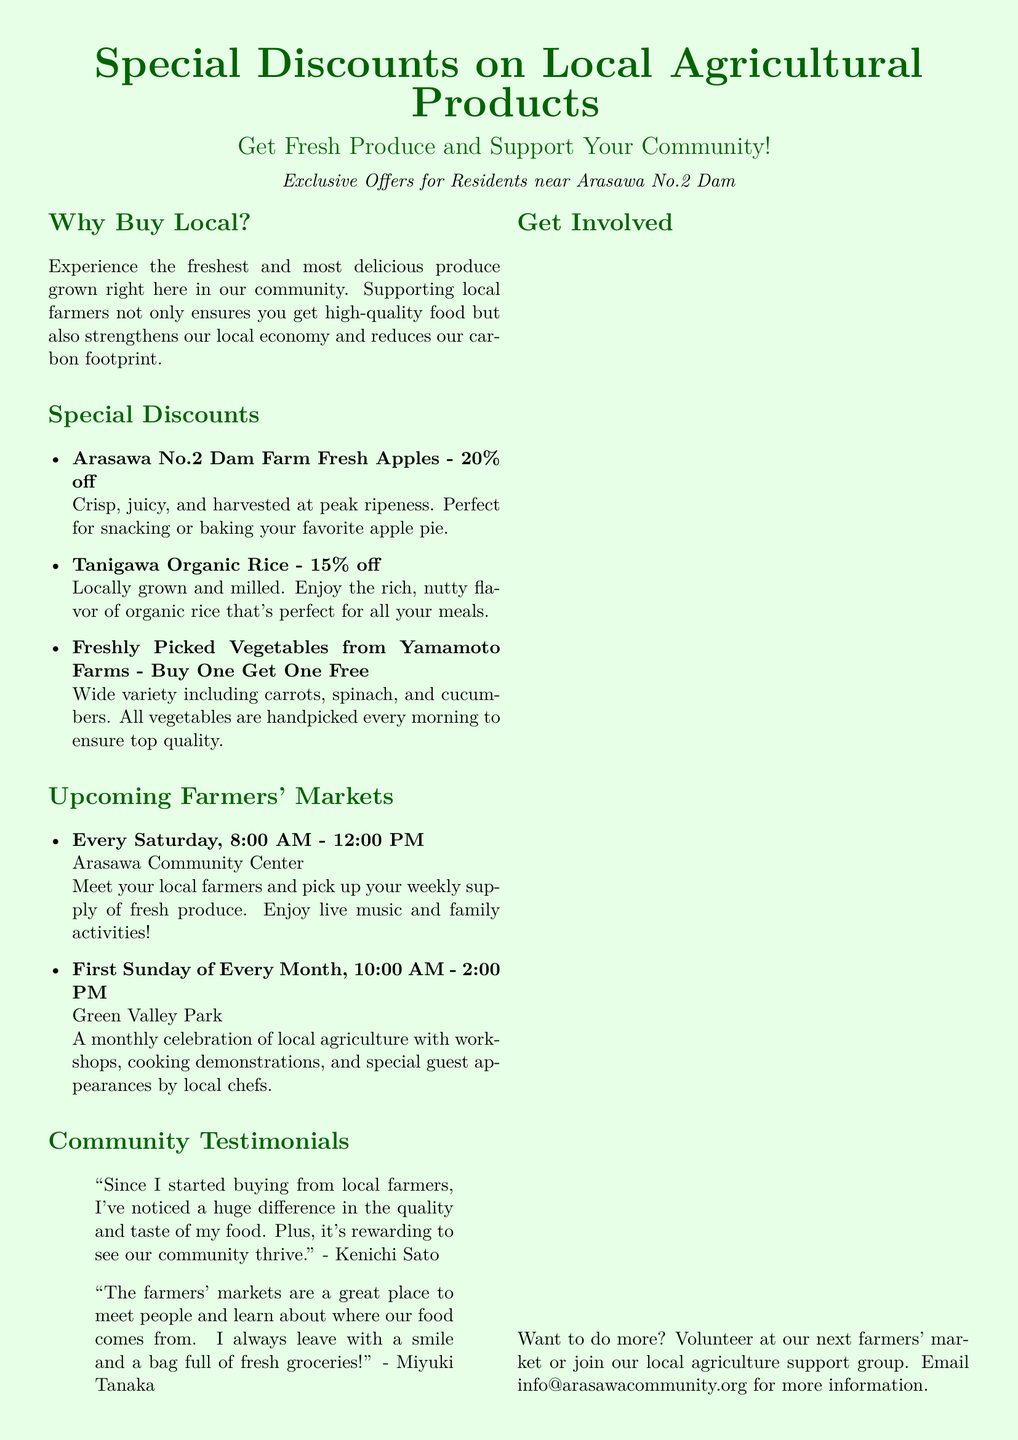What is the discount on Arasawa No.2 Dam Farm Fresh Apples? The document states that there is a 20% discount on Arasawa No.2 Dam Farm Fresh Apples.
Answer: 20% off When are the Saturday farmers' markets held? The Saturday farmers' markets are held every Saturday from 8:00 AM to 12:00 PM.
Answer: Every Saturday, 8:00 AM - 12:00 PM What type of rice is on special discount? The special discount is for Tanigawa Organic Rice.
Answer: Organic Rice What is the Buy One Get One Free offer on? The Buy One Get One Free offer is on freshly picked vegetables from Yamamoto Farms.
Answer: Freshly Picked Vegetables Who is quoted as saying that buying from local farmers makes a huge difference? Kenichi Sato is quoted as saying that buying from local farmers makes a huge difference.
Answer: Kenichi Sato What is the main reason for supporting local farmers according to the document? The document mentions that supporting local farmers strengthens our local economy and reduces our carbon footprint.
Answer: Strengthens local economy What can residents do to get involved besides buying produce? Residents can volunteer at the farmers' market or join the local agriculture support group.
Answer: Volunteer or join support group When is the monthly farmers' market celebration? The monthly farmers' market celebration is on the first Sunday of every month from 10:00 AM to 2:00 PM.
Answer: First Sunday of Every Month, 10:00 AM - 2:00 PM 